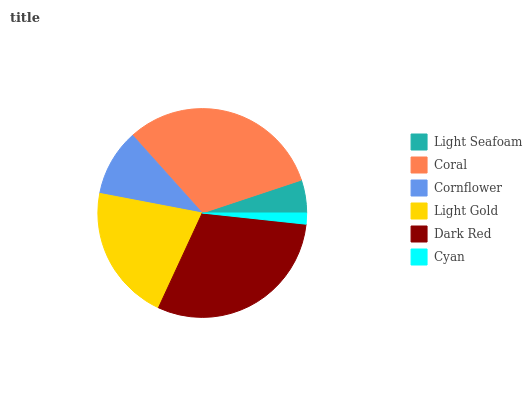Is Cyan the minimum?
Answer yes or no. Yes. Is Coral the maximum?
Answer yes or no. Yes. Is Cornflower the minimum?
Answer yes or no. No. Is Cornflower the maximum?
Answer yes or no. No. Is Coral greater than Cornflower?
Answer yes or no. Yes. Is Cornflower less than Coral?
Answer yes or no. Yes. Is Cornflower greater than Coral?
Answer yes or no. No. Is Coral less than Cornflower?
Answer yes or no. No. Is Light Gold the high median?
Answer yes or no. Yes. Is Cornflower the low median?
Answer yes or no. Yes. Is Coral the high median?
Answer yes or no. No. Is Light Gold the low median?
Answer yes or no. No. 